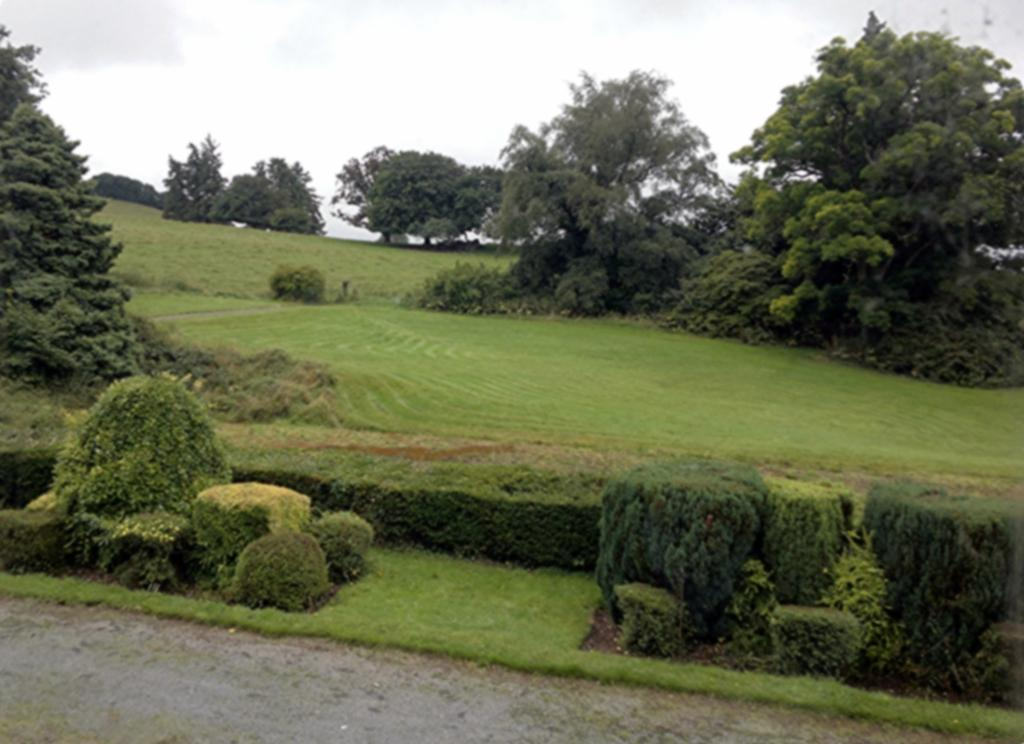What is the main feature of the image? There is a road in the image. What type of vegetation can be seen in the image? There are plants, grass, and trees in the image. What is visible in the background of the image? The sky is visible in the background of the image. How many zebras are grazing on the grass in the image? There are no zebras present in the image; it features a road, plants, grass, trees, and the sky. What type of quilt is being used to cover the trees in the image? There is no quilt present in the image, and trees are not covered by any fabric. 